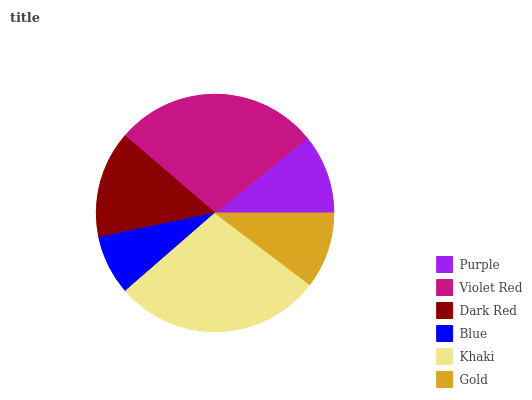Is Blue the minimum?
Answer yes or no. Yes. Is Khaki the maximum?
Answer yes or no. Yes. Is Violet Red the minimum?
Answer yes or no. No. Is Violet Red the maximum?
Answer yes or no. No. Is Violet Red greater than Purple?
Answer yes or no. Yes. Is Purple less than Violet Red?
Answer yes or no. Yes. Is Purple greater than Violet Red?
Answer yes or no. No. Is Violet Red less than Purple?
Answer yes or no. No. Is Dark Red the high median?
Answer yes or no. Yes. Is Purple the low median?
Answer yes or no. Yes. Is Gold the high median?
Answer yes or no. No. Is Blue the low median?
Answer yes or no. No. 